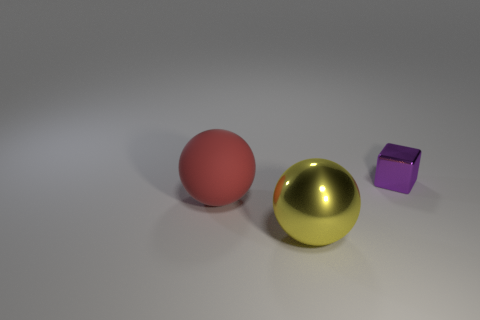What number of other things are the same size as the purple block?
Offer a very short reply. 0. What number of things are either things in front of the tiny metal cube or shiny objects in front of the tiny purple metal object?
Your answer should be very brief. 2. Does the purple object have the same material as the large object that is on the left side of the yellow ball?
Offer a terse response. No. What number of other objects are there of the same shape as the purple shiny object?
Your response must be concise. 0. There is a block on the right side of the metal thing that is on the left side of the thing that is behind the matte object; what is its material?
Keep it short and to the point. Metal. Are there an equal number of red rubber things on the right side of the large yellow object and small purple cubes?
Your answer should be compact. No. Is the material of the sphere that is right of the red object the same as the thing on the right side of the yellow ball?
Offer a very short reply. Yes. Is there any other thing that is the same material as the big red thing?
Ensure brevity in your answer.  No. Does the metallic thing in front of the shiny block have the same shape as the thing that is to the right of the yellow object?
Give a very brief answer. No. Are there fewer red matte spheres that are on the right side of the large red ball than tiny brown rubber cylinders?
Ensure brevity in your answer.  No. 